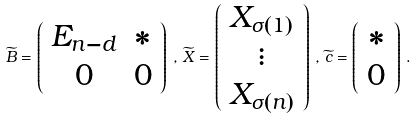Convert formula to latex. <formula><loc_0><loc_0><loc_500><loc_500>\widetilde { B } = \left ( \begin{array} { c c } E _ { n - d } & * \\ 0 & 0 \end{array} \right ) \, , \, \widetilde { X } = \left ( \begin{array} { c } X _ { \sigma ( 1 ) } \\ \vdots \\ X _ { \sigma ( n ) } \end{array} \right ) \, , \, \widetilde { c } = \left ( \begin{array} { c } * \\ 0 \end{array} \right ) \, .</formula> 